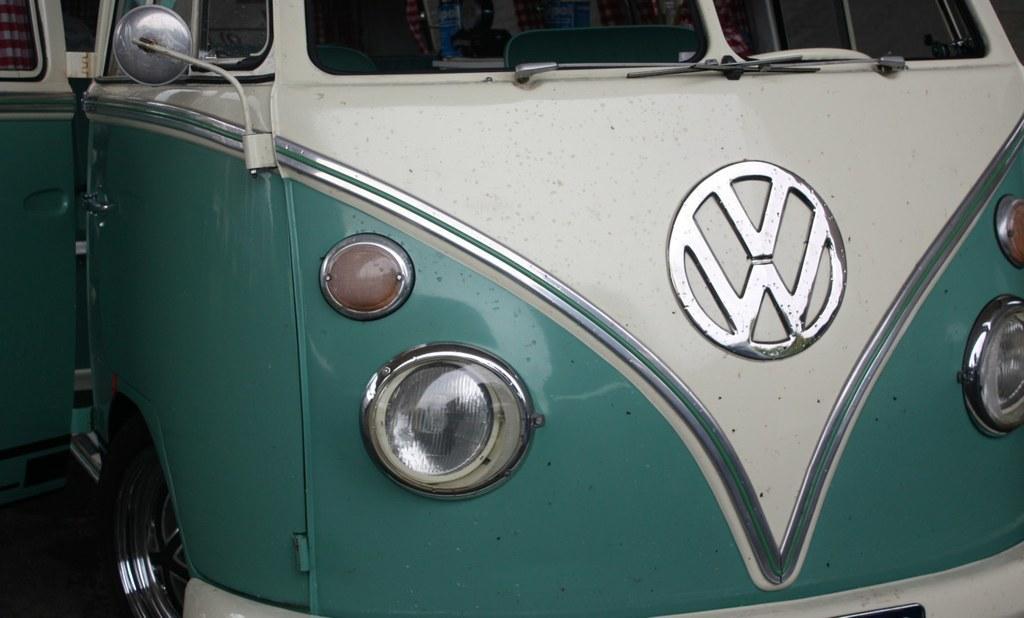Can you describe this image briefly? In this picture, we see the front part of the vehicle, which is in white and blue color. On the left side, we see the door of a vehicle and we even see a mirror and a wheel. In the middle, we see the emblem of a vehicle. 